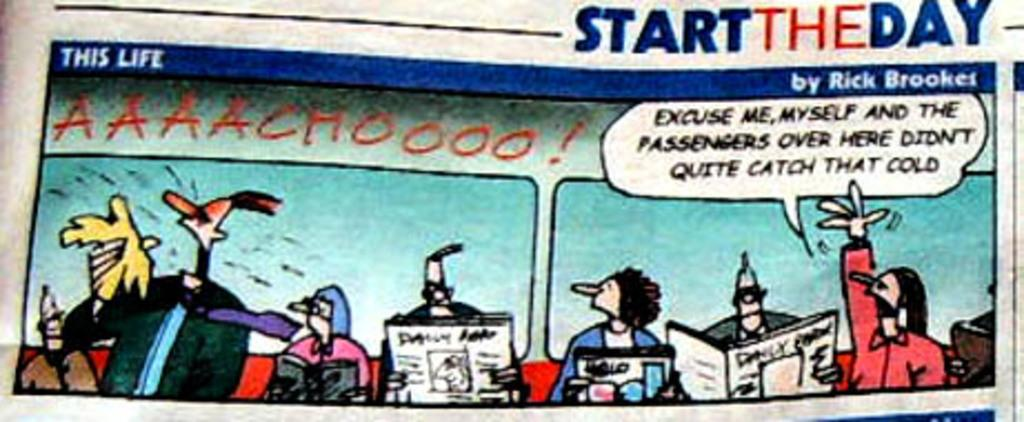<image>
Offer a succinct explanation of the picture presented. A comic strip called This Life written by Rick Brooket. 